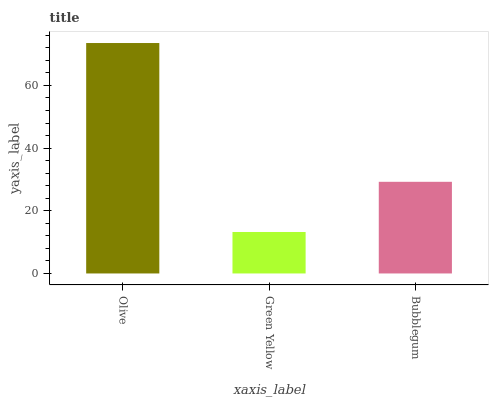Is Green Yellow the minimum?
Answer yes or no. Yes. Is Olive the maximum?
Answer yes or no. Yes. Is Bubblegum the minimum?
Answer yes or no. No. Is Bubblegum the maximum?
Answer yes or no. No. Is Bubblegum greater than Green Yellow?
Answer yes or no. Yes. Is Green Yellow less than Bubblegum?
Answer yes or no. Yes. Is Green Yellow greater than Bubblegum?
Answer yes or no. No. Is Bubblegum less than Green Yellow?
Answer yes or no. No. Is Bubblegum the high median?
Answer yes or no. Yes. Is Bubblegum the low median?
Answer yes or no. Yes. Is Green Yellow the high median?
Answer yes or no. No. Is Green Yellow the low median?
Answer yes or no. No. 